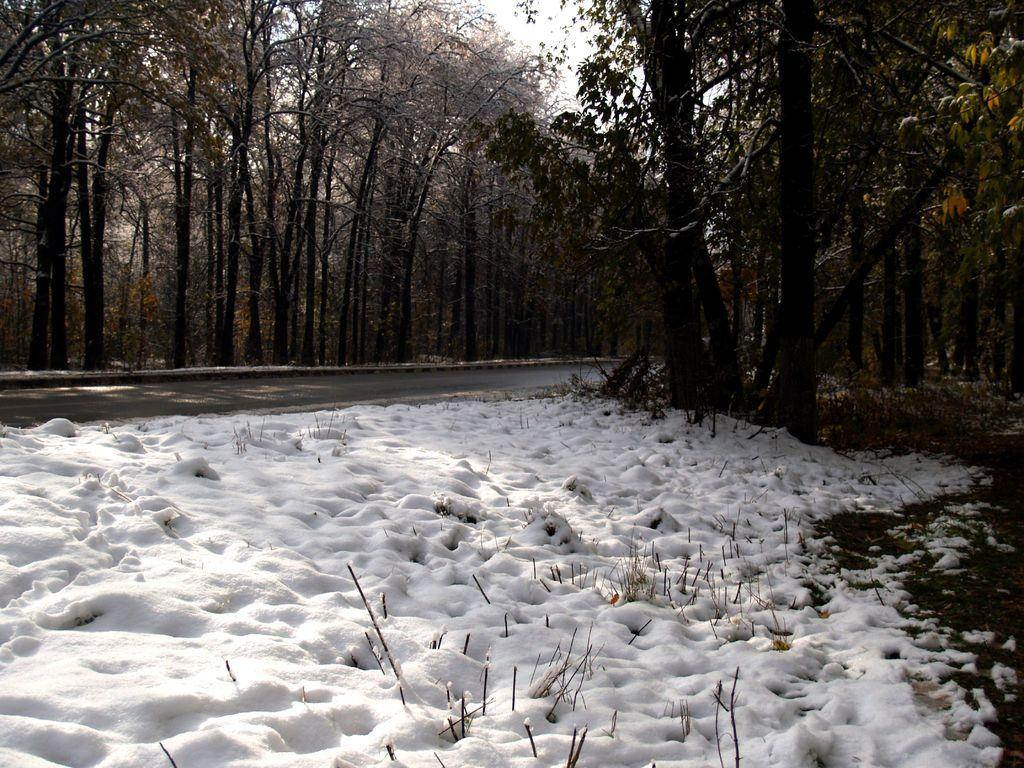What type of vegetation can be seen in the image? There are trees in the image. What is located at the bottom of the image? There is a road at the bottom of the image. What is the weather like in the image? The image shows snow, indicating a cold or wintry weather. What is visible at the top of the image? The sky is visible at the top of the image. How many attempts did the mother make to reach the range in the image? There is no reference to a mother or a range in the image, so it is not possible to answer that question. 